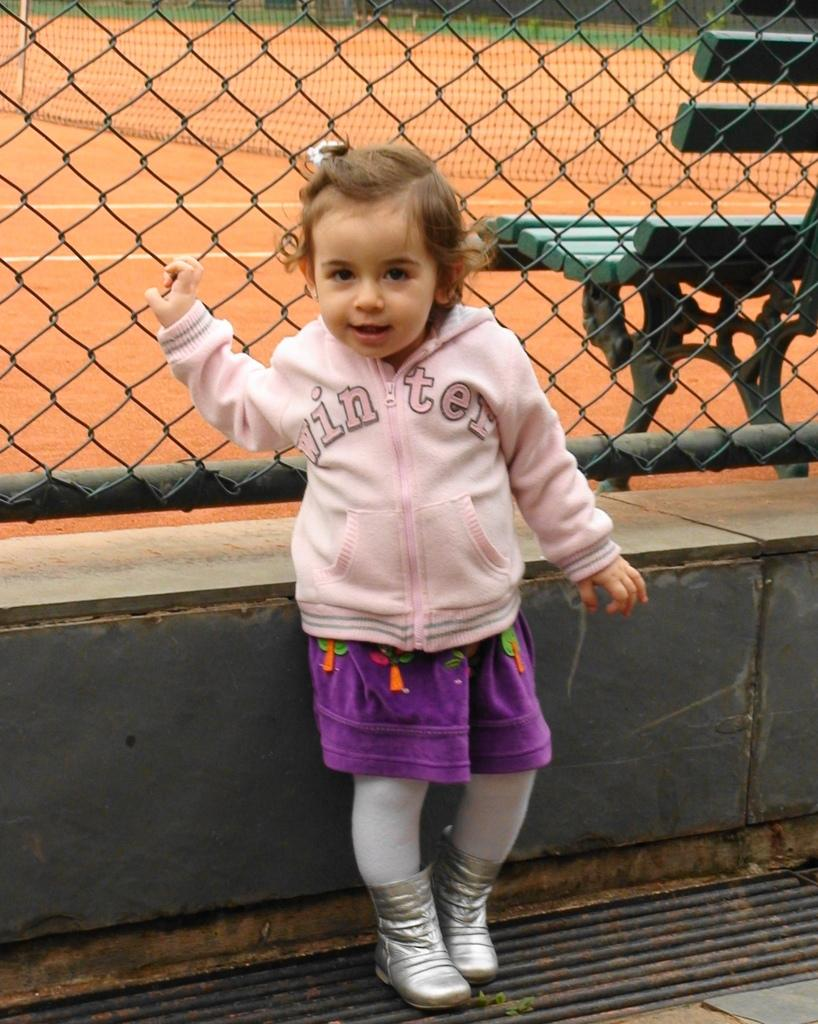Who is present in the image? There is a girl in the image. What can be seen in the background of the image? There is a fence and a green color bench behind the fence in the image. What is the ground like in the image? The ground is visible in the image. What else can be seen in the image? There is a net in the image. What type of writing can be seen on the girl's shirt in the image? There is no writing visible on the girl's shirt in the image. 